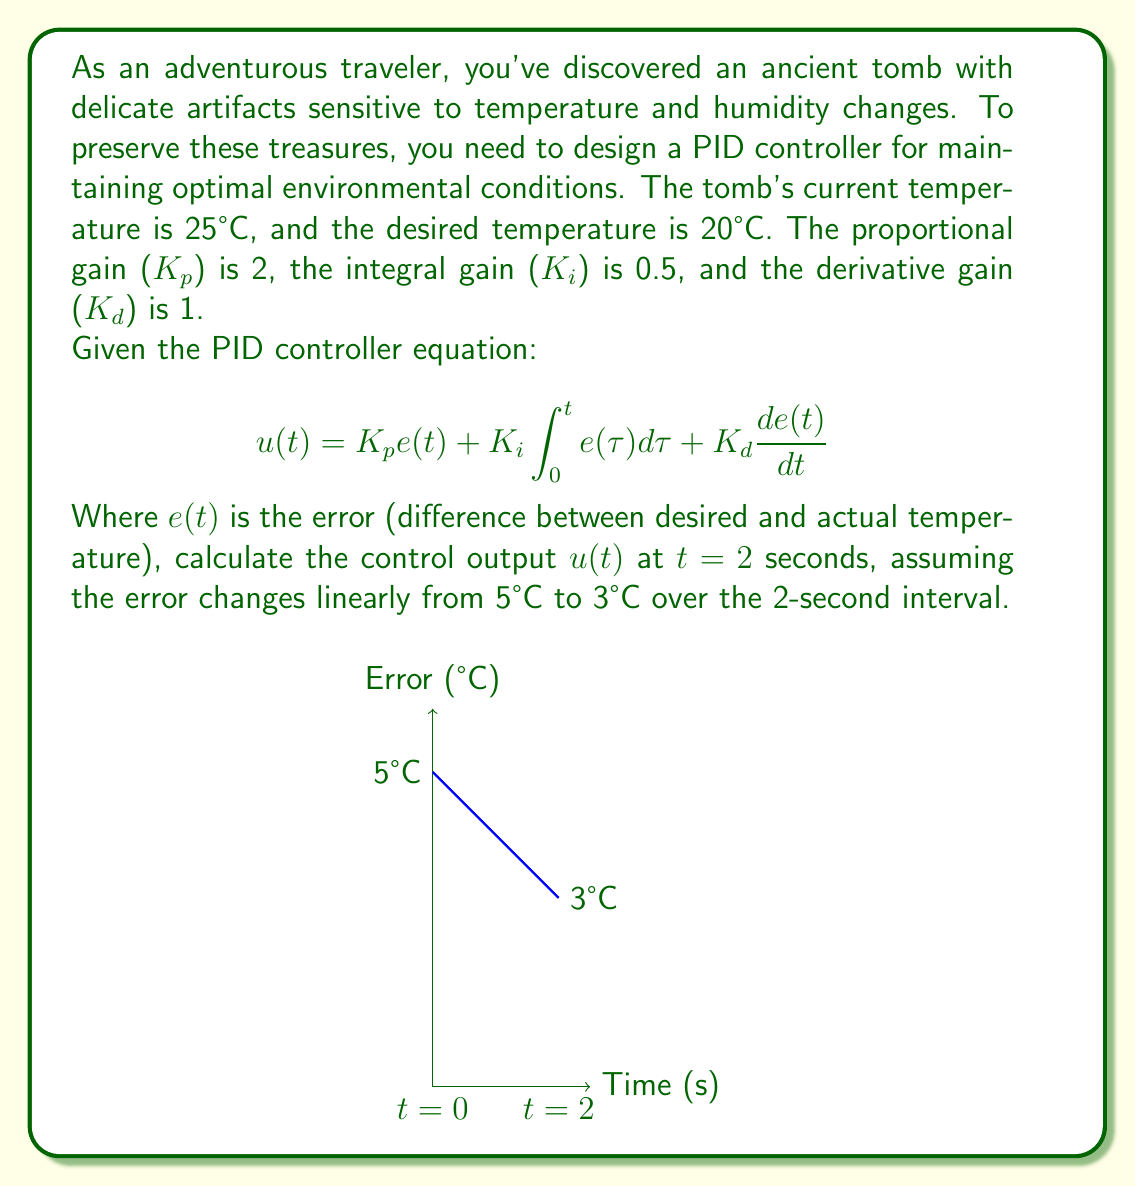What is the answer to this math problem? Let's approach this step-by-step:

1) First, we need to find the equation of the error function $e(t)$. 
   Given that it changes linearly from 5°C to 3°C over 2 seconds, we can write:
   $$e(t) = 5 - t$$

2) Now, let's calculate each term of the PID controller equation:

   a) Proportional term: $K_p e(t) = 2 * (5-2) = 6$

   b) Integral term: $K_i \int_0^t e(\tau) d\tau$
      $$\int_0^2 (5-\tau) d\tau = [5\tau - \frac{\tau^2}{2}]_0^2 = 10 - 2 = 8$$
      So, $K_i \int_0^t e(\tau) d\tau = 0.5 * 8 = 4$

   c) Derivative term: $K_d \frac{de(t)}{dt}$
      $\frac{de(t)}{dt} = -1$
      So, $K_d \frac{de(t)}{dt} = 1 * (-1) = -1$

3) Sum all terms:
   $$u(t) = 6 + 4 + (-1) = 9$$

Therefore, the control output $u(t)$ at $t = 2$ seconds is 9.
Answer: 9 